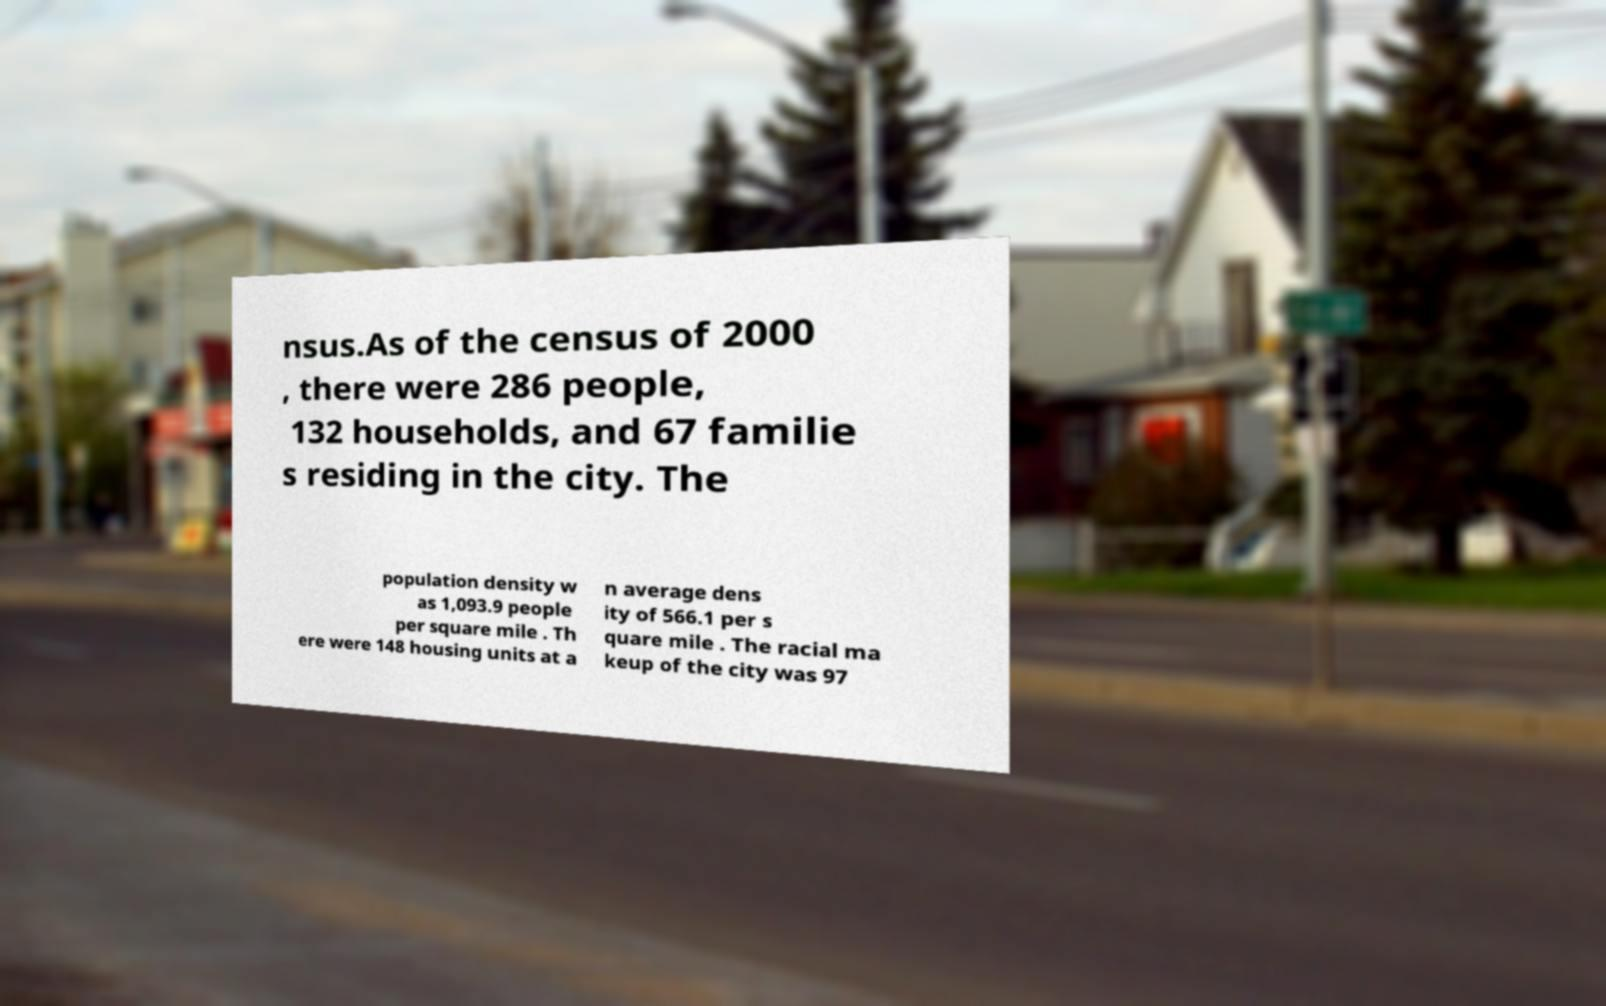Could you assist in decoding the text presented in this image and type it out clearly? nsus.As of the census of 2000 , there were 286 people, 132 households, and 67 familie s residing in the city. The population density w as 1,093.9 people per square mile . Th ere were 148 housing units at a n average dens ity of 566.1 per s quare mile . The racial ma keup of the city was 97 